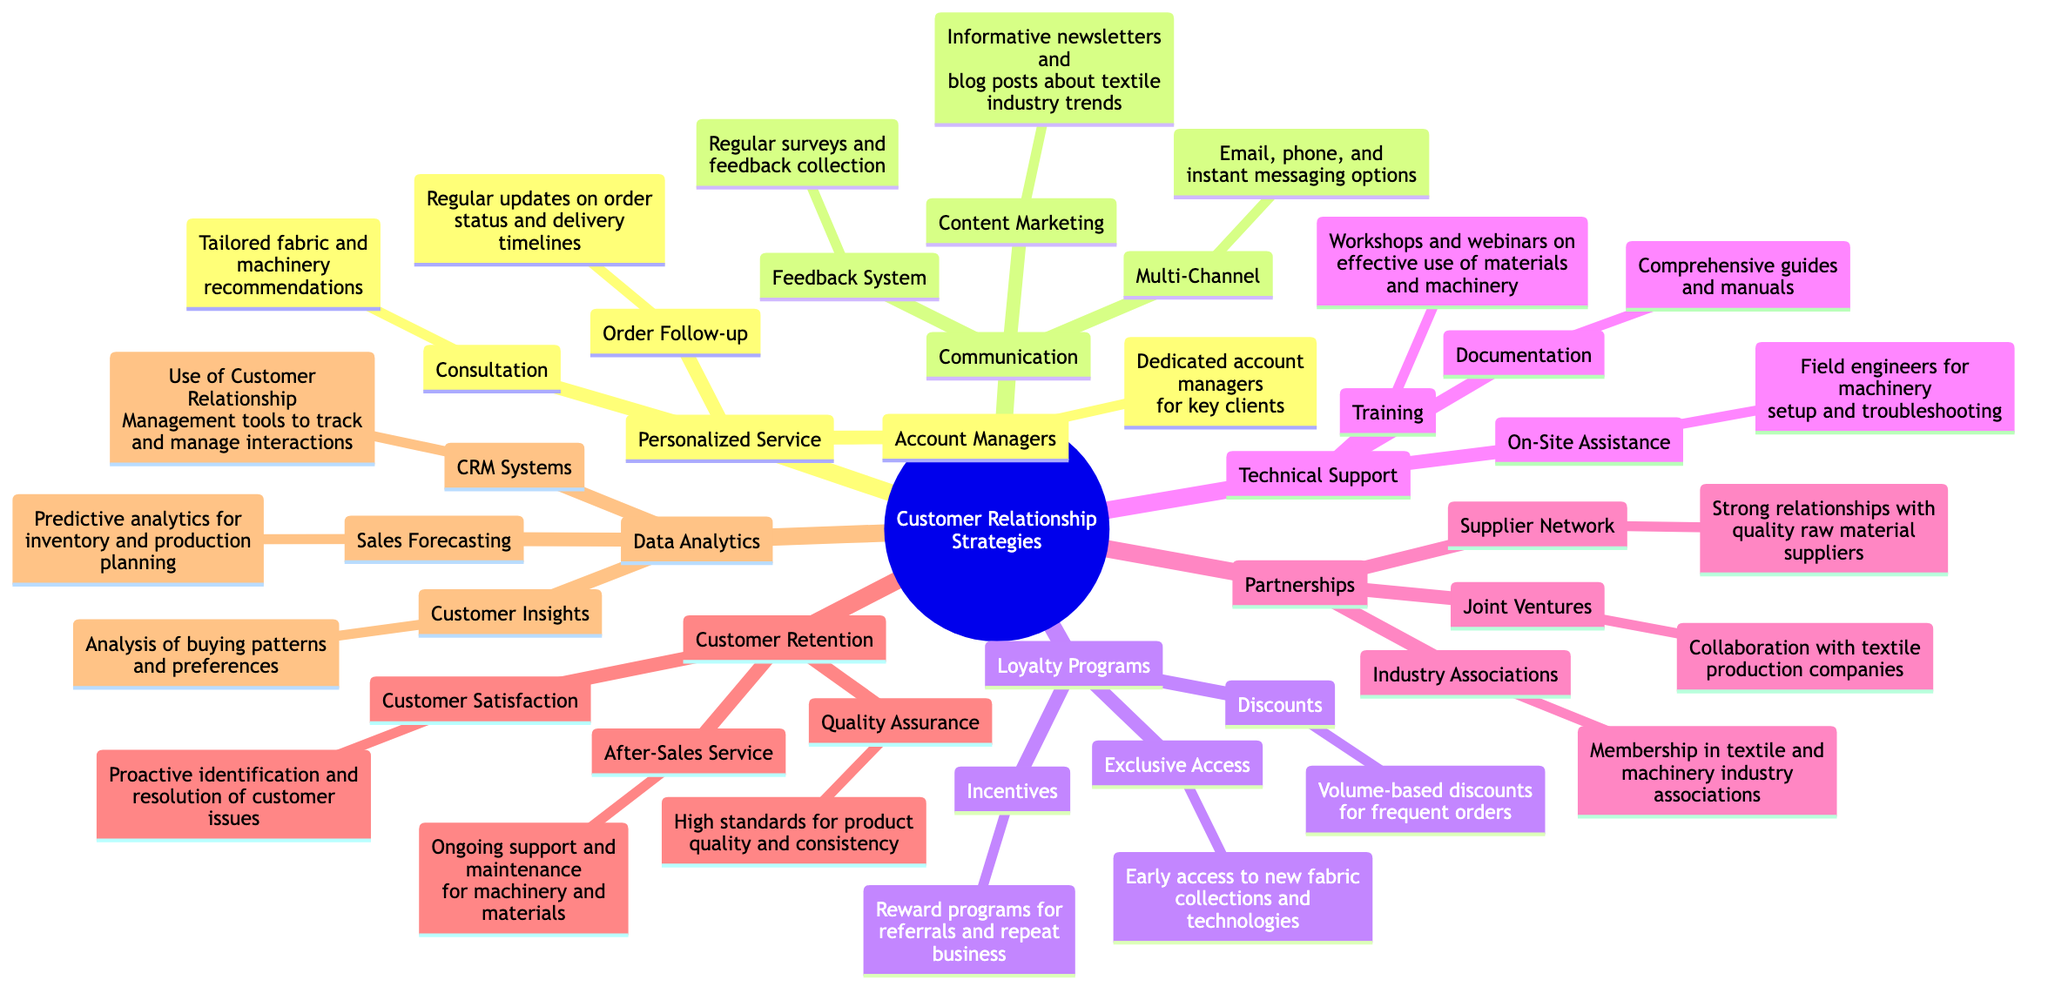What is one key component of Personalized Service? The diagram indicates that under Personalized Service, one of the key components is "Account Managers," which refers to having dedicated account managers for key clients. This can be found as a subcategory directly under the Personalized Service node.
Answer: Account Managers How many main categories are there in the Customer Relationship Strategies mind map? By examining the top level of the diagram, we find six main categories listed: Personalized Service, Communication, Loyalty Programs, Technical Support, Partnerships, Customer Retention, and Data Analytics. Counting these gives us a total of seven.
Answer: 7 What type of program rewards referrals and repeat business? In the Loyalty Programs section of the diagram, it specifies that "Incentives" are used for rewarding referrals and repeat business. This indicates a specific type of program aimed at enhancing loyalty through rewards.
Answer: Incentives Which strategy includes analysis of buying patterns? The Data Analytics category in the mind map discusses several strategies, and the specific strategy related to analyzing buying patterns is labeled as "Customer Insights." This is directly stated in the Data Analytics section.
Answer: Customer Insights What support is provided on-site according to the Technical Support category? The Technical Support category lists "On-Site Assistance" as a support option, indicating the provision of field engineers for machinery setup and troubleshooting. This highlights the hands-on support aspect of technical assistance.
Answer: On-Site Assistance How does the diagram indicate that customer satisfaction is maintained? Under the Customer Retention category, it is stated that customer satisfaction is maintained through "Proactive identification and resolution of customer issues." This reflects a strategy focused on ensuring customers' needs are met promptly.
Answer: Proactive identification and resolution of customer issues What is offered to frequent orders in the Loyalty Programs section? The Loyalty Programs section specifies that "Discounts" are provided for frequent orders, showcasing a strategy to incentivize repeat purchasing through financial benefits.
Answer: Discounts 